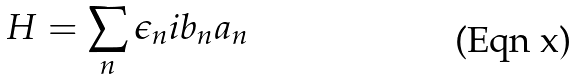Convert formula to latex. <formula><loc_0><loc_0><loc_500><loc_500>H = \sum _ { n } \epsilon _ { n } i b _ { n } a _ { n }</formula> 